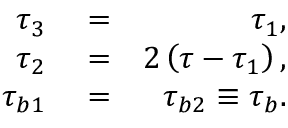<formula> <loc_0><loc_0><loc_500><loc_500>\begin{array} { r l r } { \tau _ { 3 } } & = } & { \tau _ { 1 } , } \\ { \tau _ { 2 } } & = } & { 2 \left ( \tau - \tau _ { 1 } \right ) , } \\ { \tau _ { b 1 } } & = } & { \tau _ { b 2 } \equiv \tau _ { b } . } \end{array}</formula> 